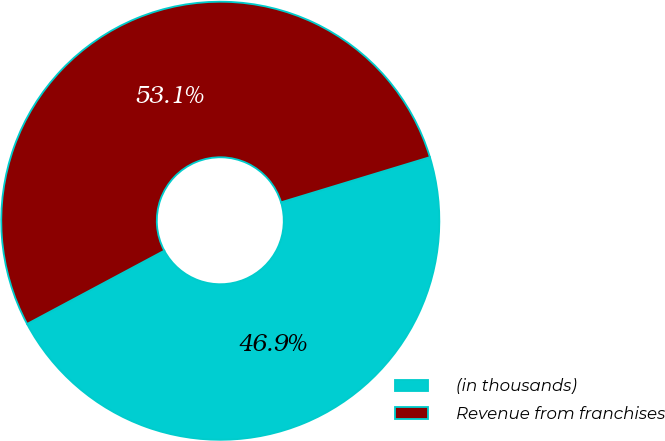Convert chart. <chart><loc_0><loc_0><loc_500><loc_500><pie_chart><fcel>(in thousands)<fcel>Revenue from franchises<nl><fcel>46.88%<fcel>53.12%<nl></chart> 